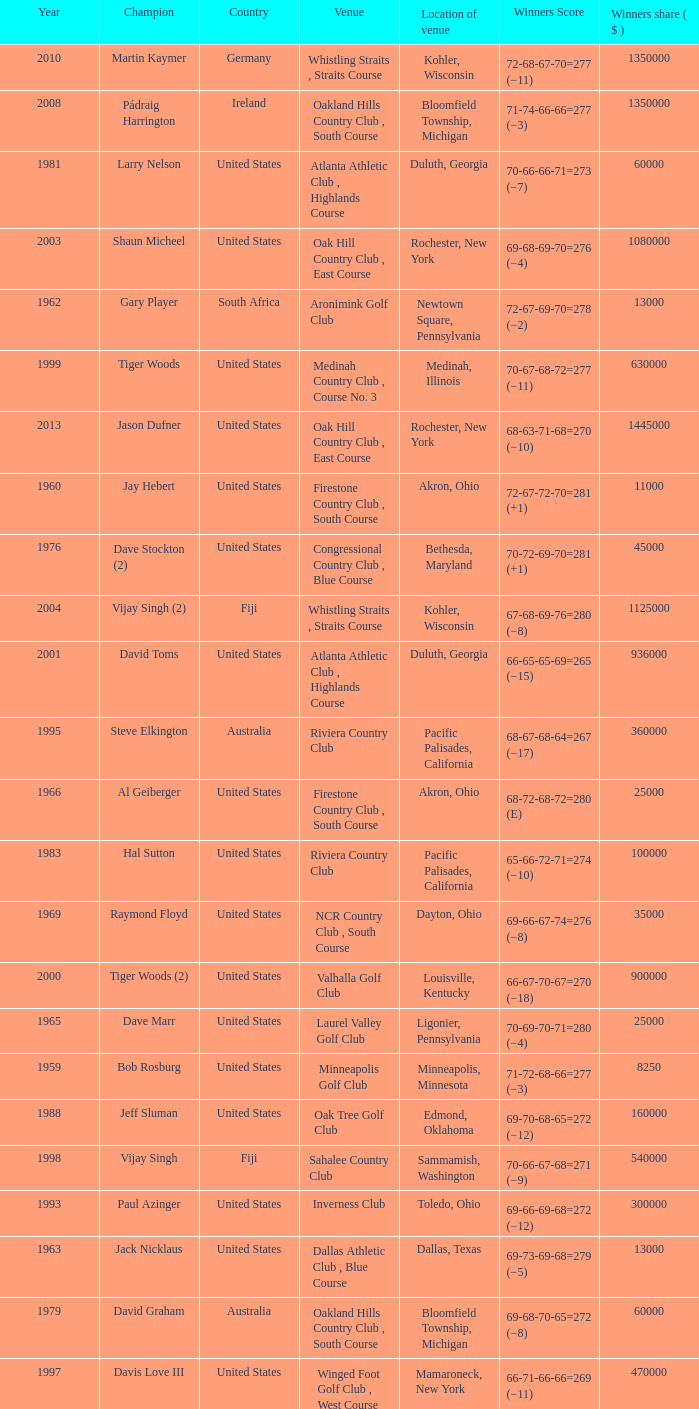Where is the Bellerive Country Club venue located? St. Louis, Missouri. 